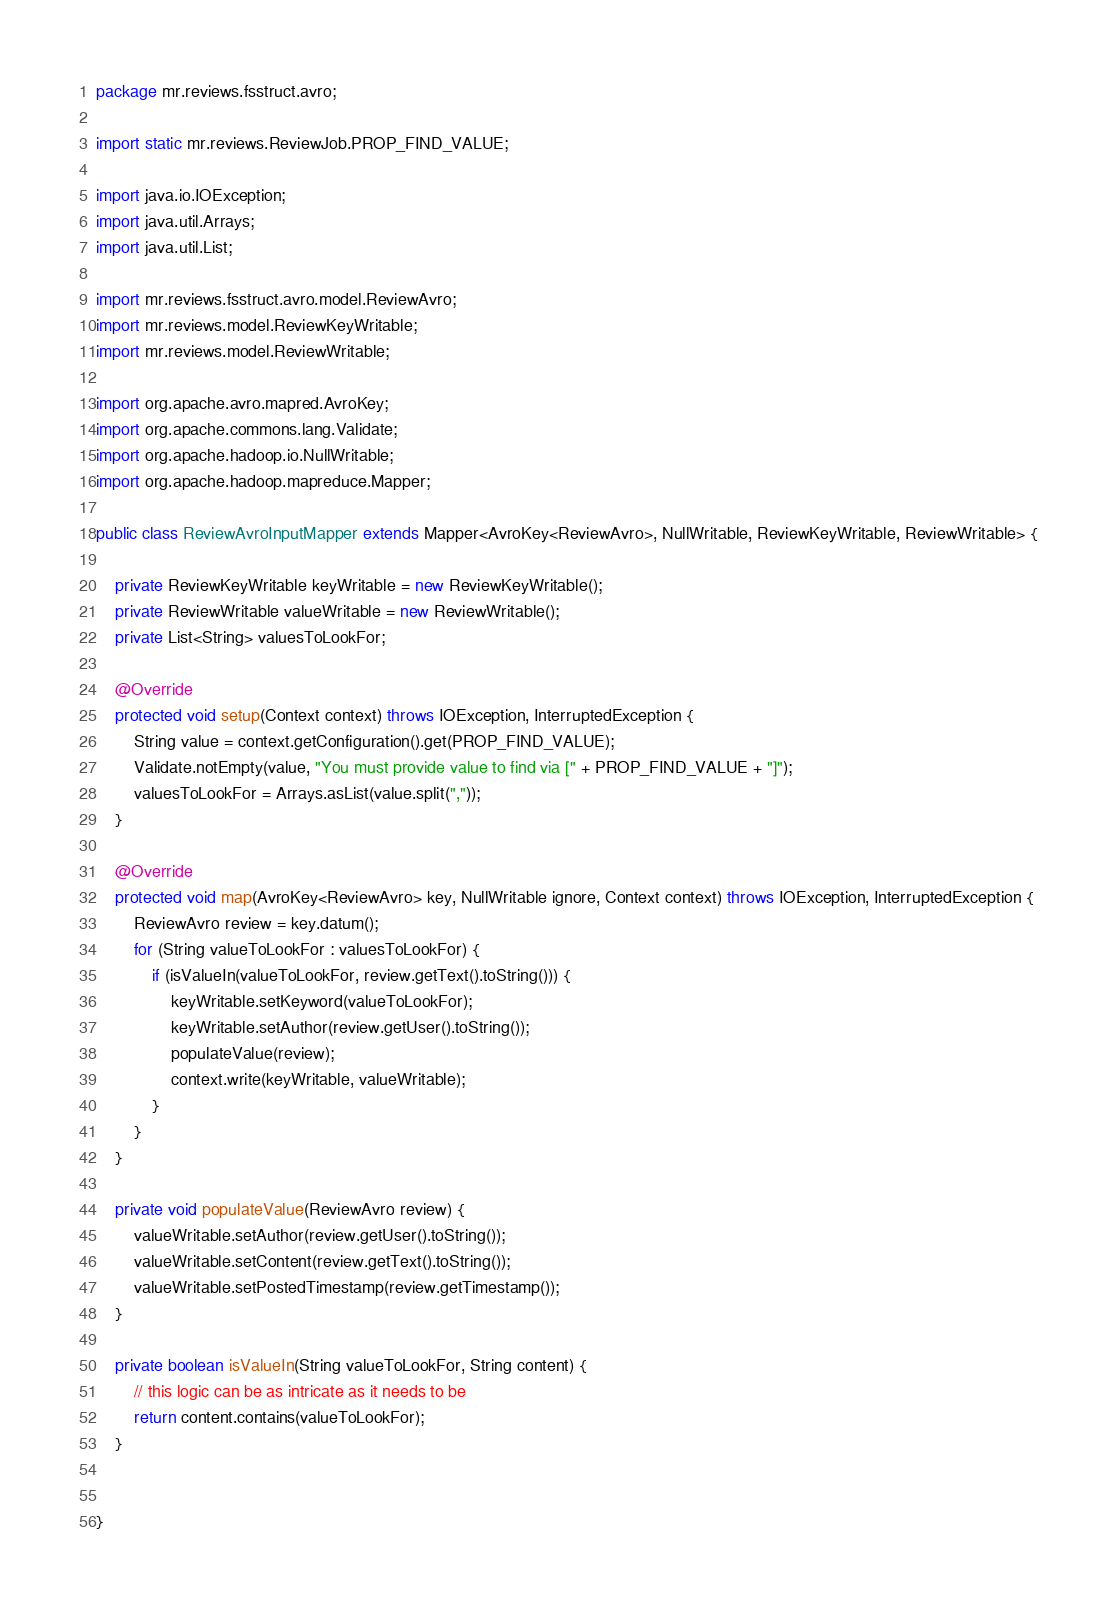<code> <loc_0><loc_0><loc_500><loc_500><_Java_>package mr.reviews.fsstruct.avro;

import static mr.reviews.ReviewJob.PROP_FIND_VALUE;

import java.io.IOException;
import java.util.Arrays;
import java.util.List;

import mr.reviews.fsstruct.avro.model.ReviewAvro;
import mr.reviews.model.ReviewKeyWritable;
import mr.reviews.model.ReviewWritable;

import org.apache.avro.mapred.AvroKey;
import org.apache.commons.lang.Validate;
import org.apache.hadoop.io.NullWritable;
import org.apache.hadoop.mapreduce.Mapper;

public class ReviewAvroInputMapper extends Mapper<AvroKey<ReviewAvro>, NullWritable, ReviewKeyWritable, ReviewWritable> {

    private ReviewKeyWritable keyWritable = new ReviewKeyWritable();
    private ReviewWritable valueWritable = new ReviewWritable();
    private List<String> valuesToLookFor;

    @Override
    protected void setup(Context context) throws IOException, InterruptedException {
        String value = context.getConfiguration().get(PROP_FIND_VALUE);
        Validate.notEmpty(value, "You must provide value to find via [" + PROP_FIND_VALUE + "]");
        valuesToLookFor = Arrays.asList(value.split(","));
    }

    @Override
    protected void map(AvroKey<ReviewAvro> key, NullWritable ignore, Context context) throws IOException, InterruptedException {
        ReviewAvro review = key.datum();
        for (String valueToLookFor : valuesToLookFor) {
            if (isValueIn(valueToLookFor, review.getText().toString())) {
                keyWritable.setKeyword(valueToLookFor);
                keyWritable.setAuthor(review.getUser().toString());
                populateValue(review);
                context.write(keyWritable, valueWritable);
            }
        }
    }

    private void populateValue(ReviewAvro review) {
        valueWritable.setAuthor(review.getUser().toString());
        valueWritable.setContent(review.getText().toString());
        valueWritable.setPostedTimestamp(review.getTimestamp());
    }

    private boolean isValueIn(String valueToLookFor, String content) {
        // this logic can be as intricate as it needs to be
        return content.contains(valueToLookFor);
    }

   
}
</code> 